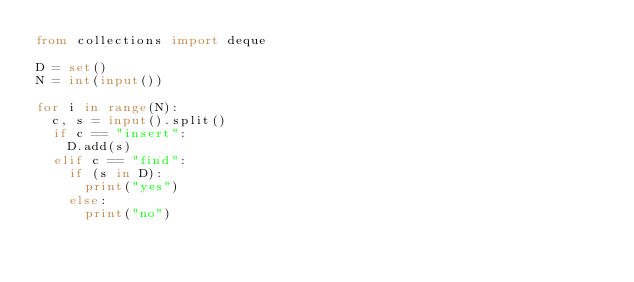Convert code to text. <code><loc_0><loc_0><loc_500><loc_500><_Python_>from collections import deque

D = set()
N = int(input())

for i in range(N):
	c, s = input().split()
	if c == "insert":
		D.add(s)
	elif c == "find":
		if (s in D):
			print("yes")
		else:
			print("no")</code> 